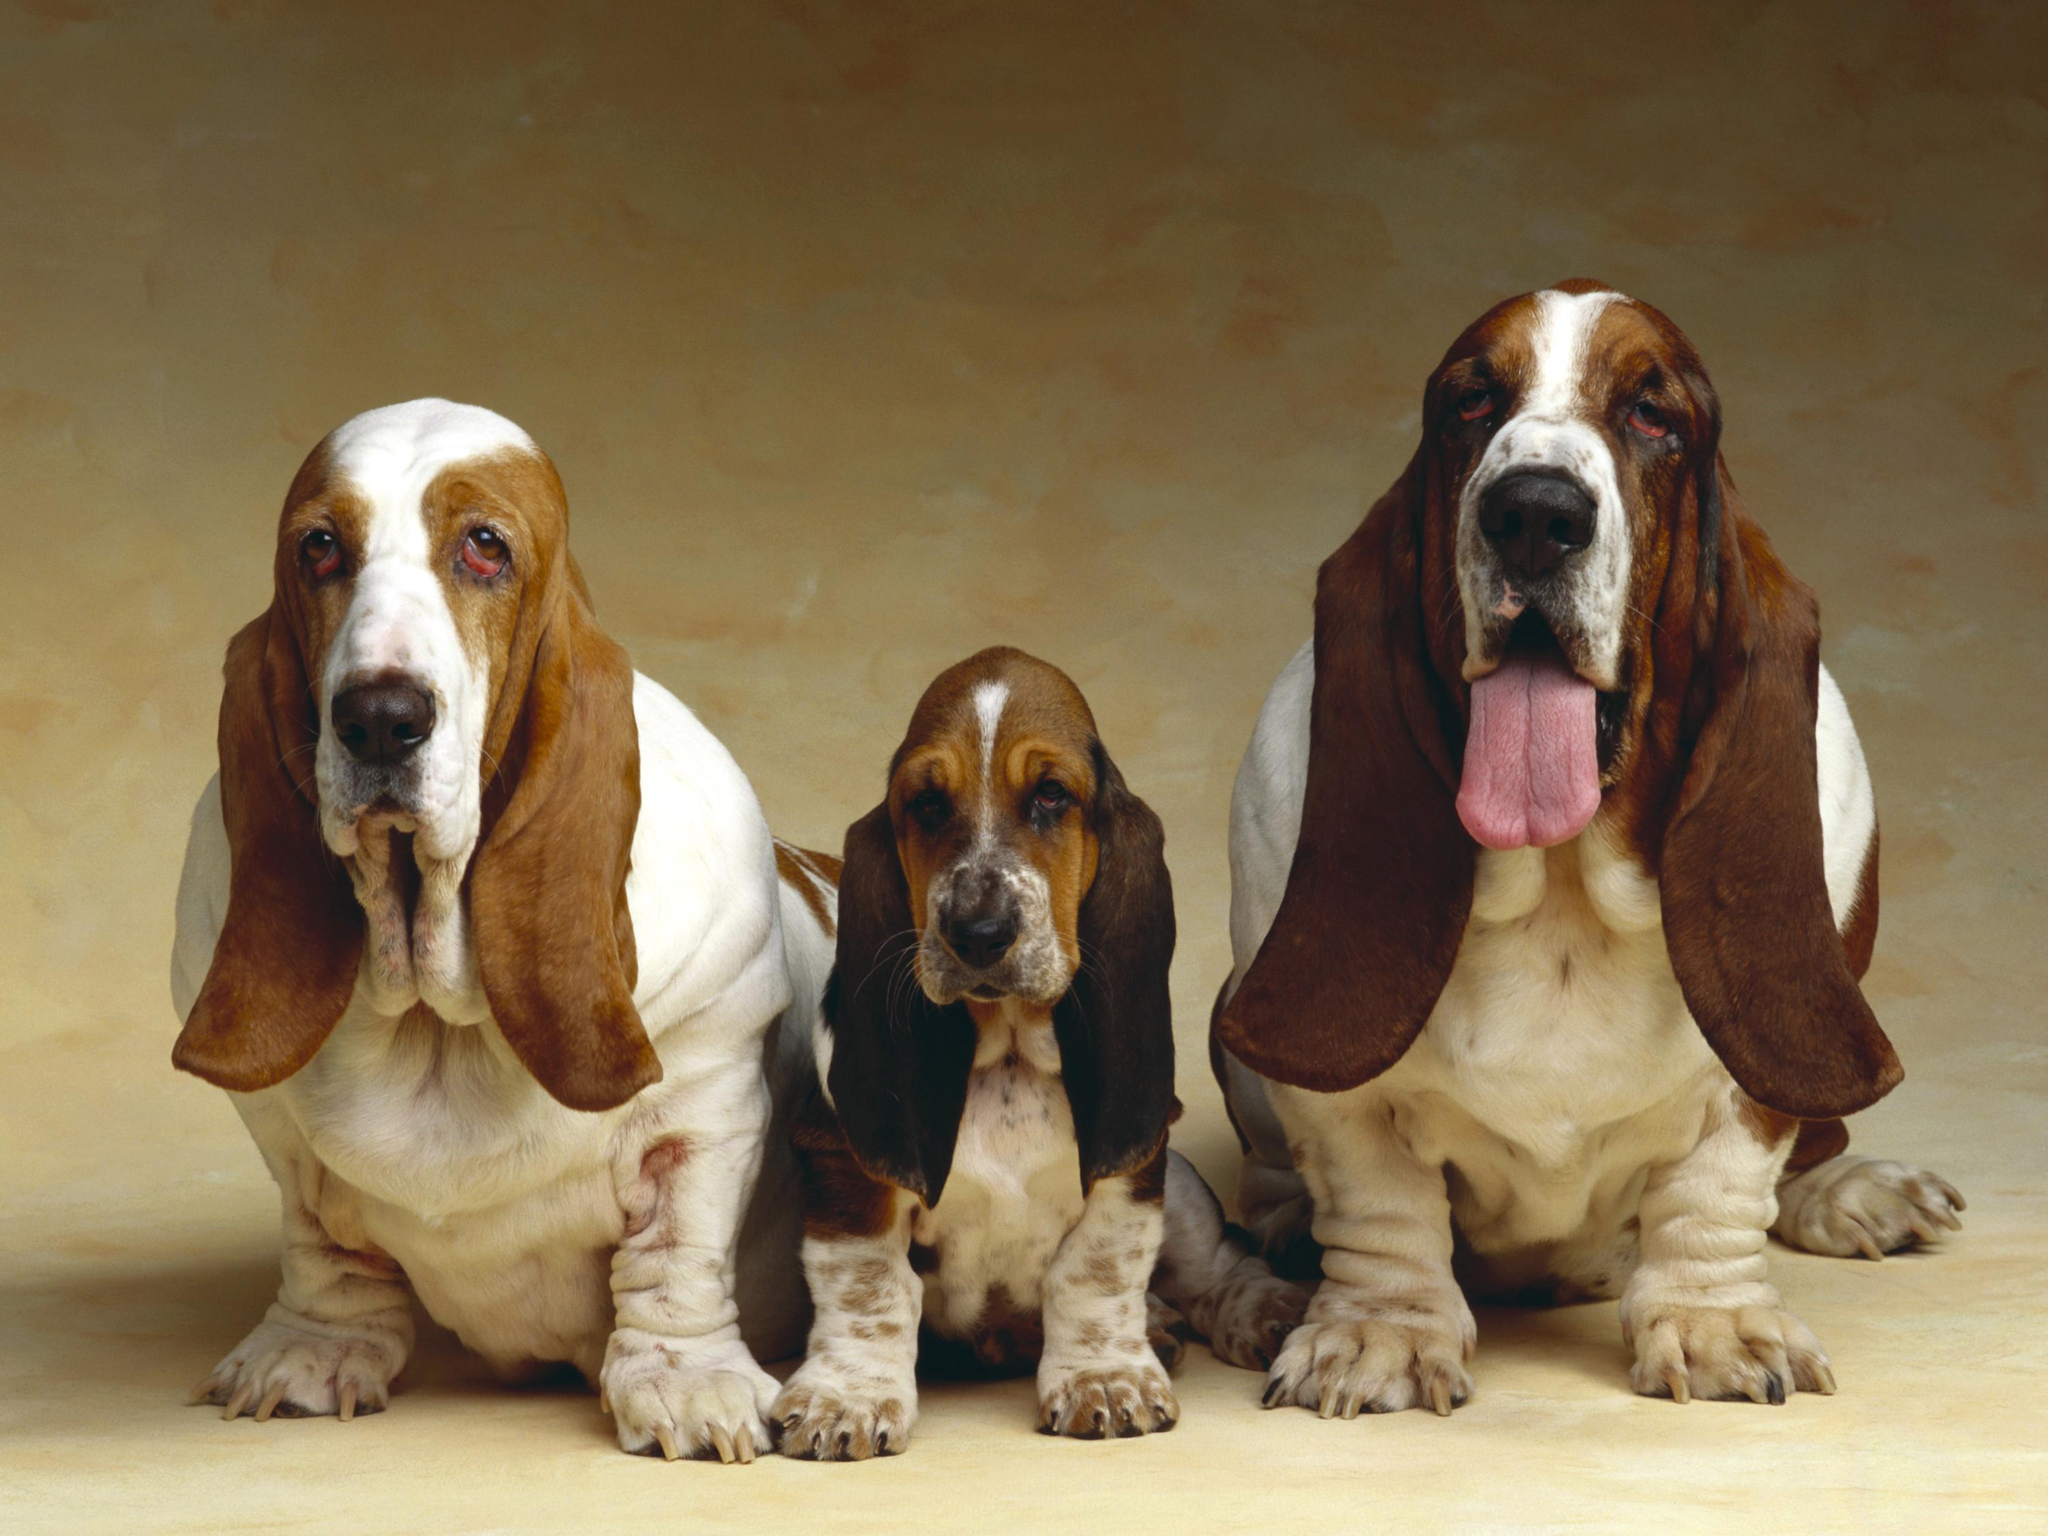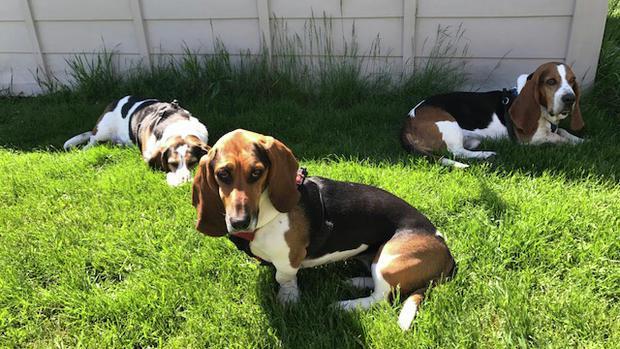The first image is the image on the left, the second image is the image on the right. Evaluate the accuracy of this statement regarding the images: "There are three dogs in the grass in the right image.". Is it true? Answer yes or no. Yes. 